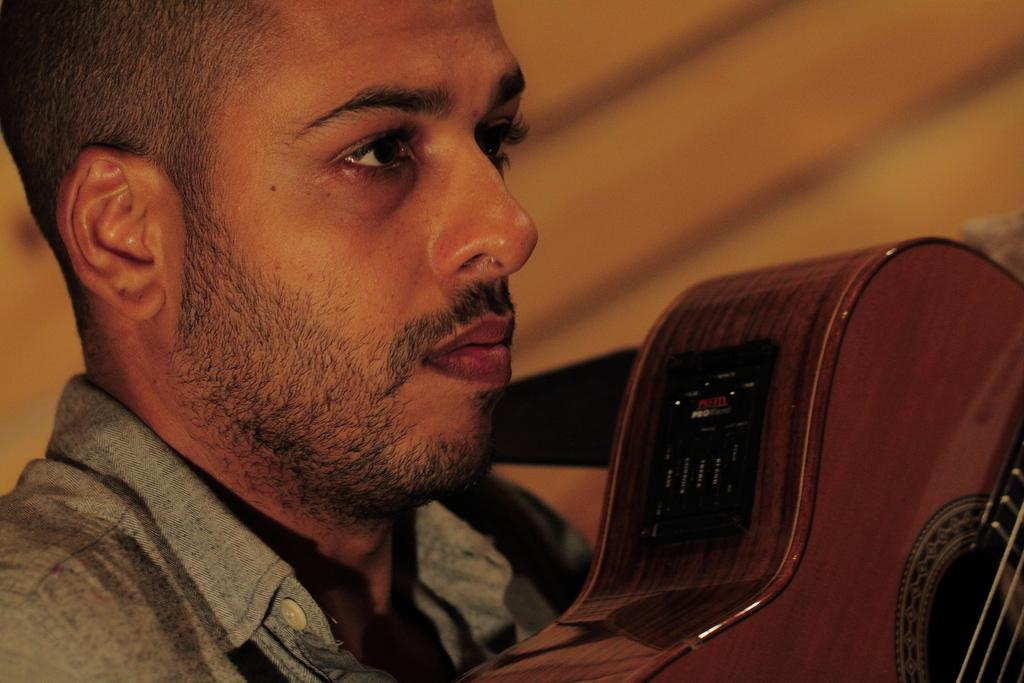What is the main subject of the image? There is a man in the image. What is the man holding in the image? The man is holding a music instrument. Can you describe any additional details about the music instrument? There is a sticker on the music instrument. What color is the background behind the man? The background behind the man is blue. What type of produce is being harvested in the image? There is no produce or harvesting activity present in the image. Is there a volcano visible in the background of the image? No, there is no volcano present in the image. 